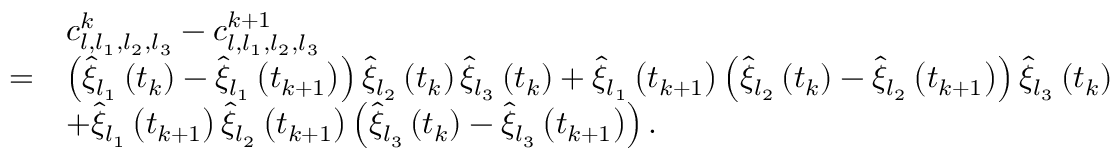Convert formula to latex. <formula><loc_0><loc_0><loc_500><loc_500>\begin{array} { r l } & { c _ { l , l _ { 1 } , l _ { 2 } , l _ { 3 } } ^ { k } - c _ { l , l _ { 1 } , l _ { 2 } , l _ { 3 } } ^ { k + 1 } } \\ { = } & { \left ( \widehat { \xi } _ { l _ { 1 } } \left ( t _ { k } \right ) - \widehat { \xi } _ { l _ { 1 } } \left ( t _ { k + 1 } \right ) \right ) \widehat { \xi } _ { l _ { 2 } } \left ( t _ { k } \right ) \widehat { \xi } _ { l _ { 3 } } \left ( t _ { k } \right ) + \widehat { \xi } _ { l _ { 1 } } \left ( t _ { k + 1 } \right ) \left ( \widehat { \xi } _ { l _ { 2 } } \left ( t _ { k } \right ) - \widehat { \xi } _ { l _ { 2 } } \left ( t _ { k + 1 } \right ) \right ) \widehat { \xi } _ { l _ { 3 } } \left ( t _ { k } \right ) } \\ & { + \widehat { \xi } _ { l _ { 1 } } \left ( t _ { k + 1 } \right ) \widehat { \xi } _ { l _ { 2 } } \left ( t _ { k + 1 } \right ) \left ( \widehat { \xi } _ { l _ { 3 } } \left ( t _ { k } \right ) - \widehat { \xi } _ { l _ { 3 } } \left ( t _ { k + 1 } \right ) \right ) . } \end{array}</formula> 